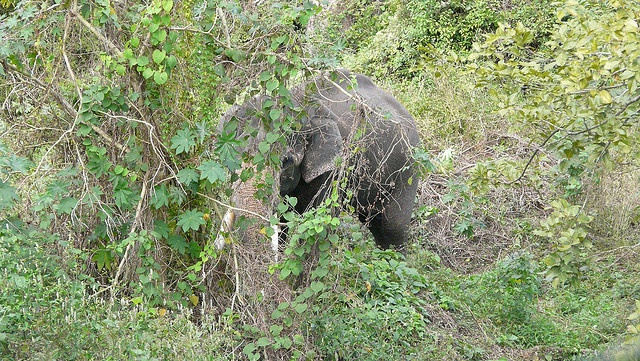Describe the objects in this image and their specific colors. I can see a elephant in darkgreen, darkgray, gray, black, and olive tones in this image. 